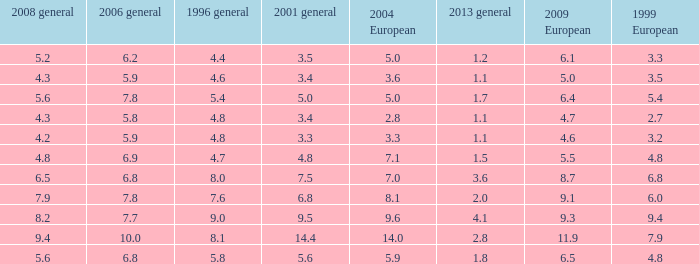What is the lowest value for 2004 European when 1999 European is 3.3 and less than 4.4 in 1996 general? None. 